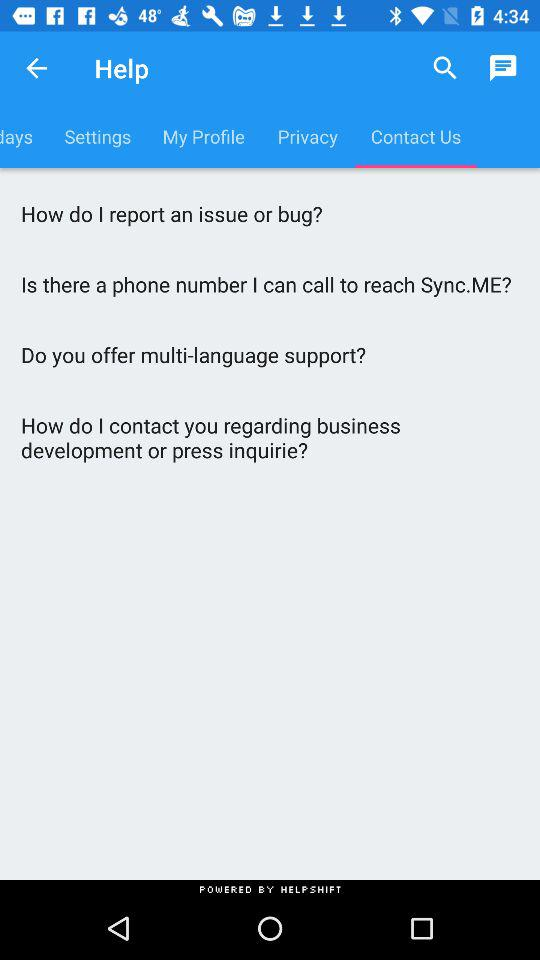Which tab is currently selected? The currently selected tab is "Contact Us". 